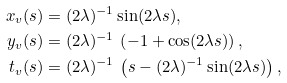Convert formula to latex. <formula><loc_0><loc_0><loc_500><loc_500>x _ { v } ( s ) & = ( 2 \lambda ) ^ { - 1 } \sin ( 2 \lambda s ) , \\ y _ { v } ( s ) & = ( 2 \lambda ) ^ { - 1 } \, \left ( - 1 + \cos ( 2 \lambda s ) \right ) , \\ t _ { v } ( s ) & = ( 2 \lambda ) ^ { - 1 } \, \left ( s - ( 2 \lambda ) ^ { - 1 } \sin ( 2 \lambda s ) \right ) ,</formula> 